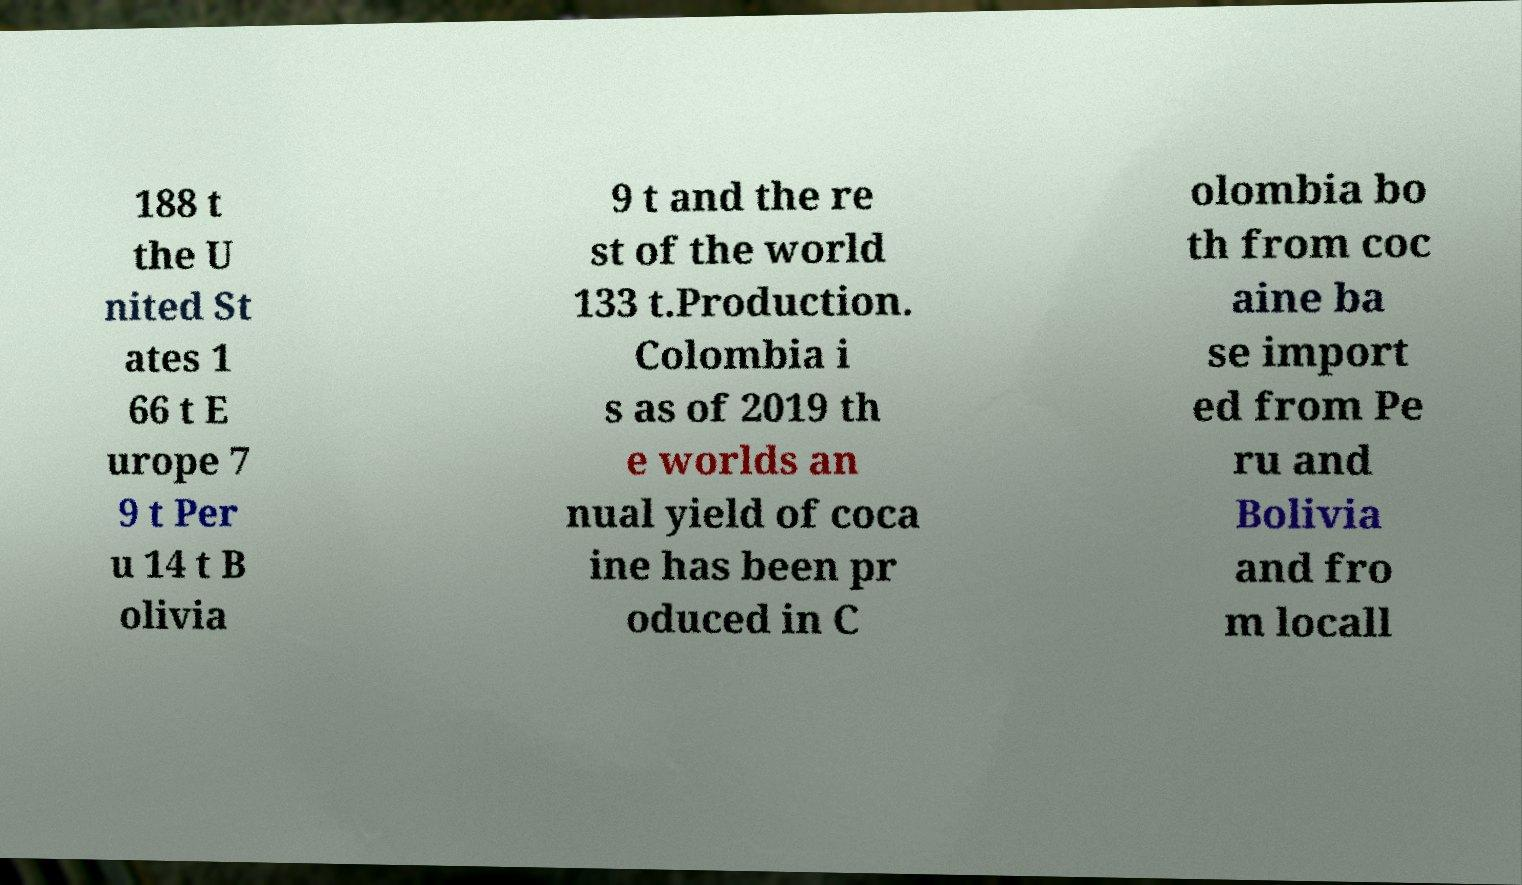There's text embedded in this image that I need extracted. Can you transcribe it verbatim? 188 t the U nited St ates 1 66 t E urope 7 9 t Per u 14 t B olivia 9 t and the re st of the world 133 t.Production. Colombia i s as of 2019 th e worlds an nual yield of coca ine has been pr oduced in C olombia bo th from coc aine ba se import ed from Pe ru and Bolivia and fro m locall 